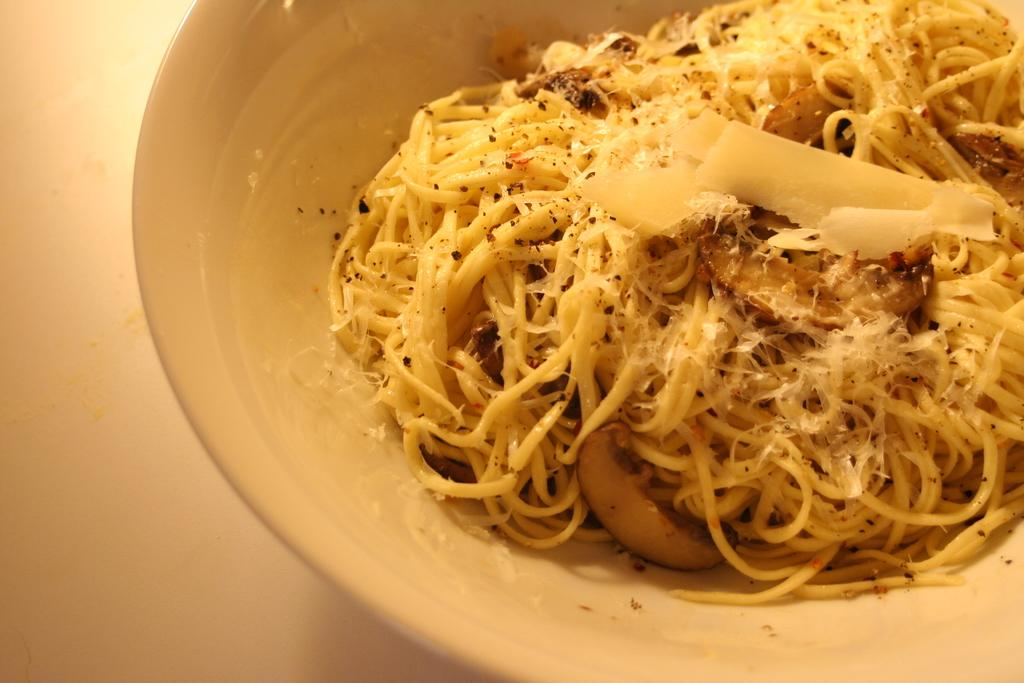What is located in the center of the image? There is a bowl in the center of the image. What is inside the bowl? The bowl contains noodles. What is the primary piece of furniture visible in the image? There is a table at the bottom of the image. What type of bone can be seen in the image? There is no bone present in the image. How many passengers are visible in the image? There are no passengers visible in the image. 